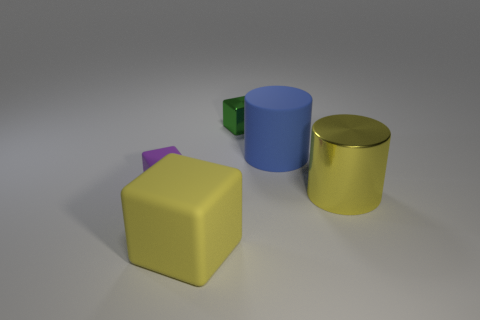Does the matte cylinder have the same size as the metallic object that is behind the big yellow cylinder?
Your response must be concise. No. How many shiny things are either small objects or yellow objects?
Offer a very short reply. 2. Is the number of big yellow metal cubes greater than the number of large blue matte cylinders?
Your answer should be very brief. No. What is the size of the matte block that is the same color as the metal cylinder?
Your answer should be very brief. Large. There is a large matte thing that is to the right of the large yellow rubber thing that is to the right of the small rubber object; what shape is it?
Your response must be concise. Cylinder. There is a cylinder that is behind the tiny block to the left of the large yellow cube; is there a purple cube that is to the right of it?
Ensure brevity in your answer.  No. There is a matte block that is the same size as the matte cylinder; what color is it?
Give a very brief answer. Yellow. What is the shape of the rubber thing that is both behind the large rubber cube and to the left of the small green thing?
Offer a terse response. Cube. What is the size of the cylinder to the left of the yellow object to the right of the blue matte cylinder?
Give a very brief answer. Large. How many metal blocks have the same color as the large metallic object?
Ensure brevity in your answer.  0. 